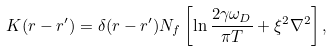<formula> <loc_0><loc_0><loc_500><loc_500>K ( { r } - { r } ^ { \prime } ) = \delta ( { r } - { r } ^ { \prime } ) N _ { f } \left [ \ln \frac { 2 \gamma \omega _ { D } } { \pi T } + \xi ^ { 2 } \nabla ^ { 2 } \right ] ,</formula> 